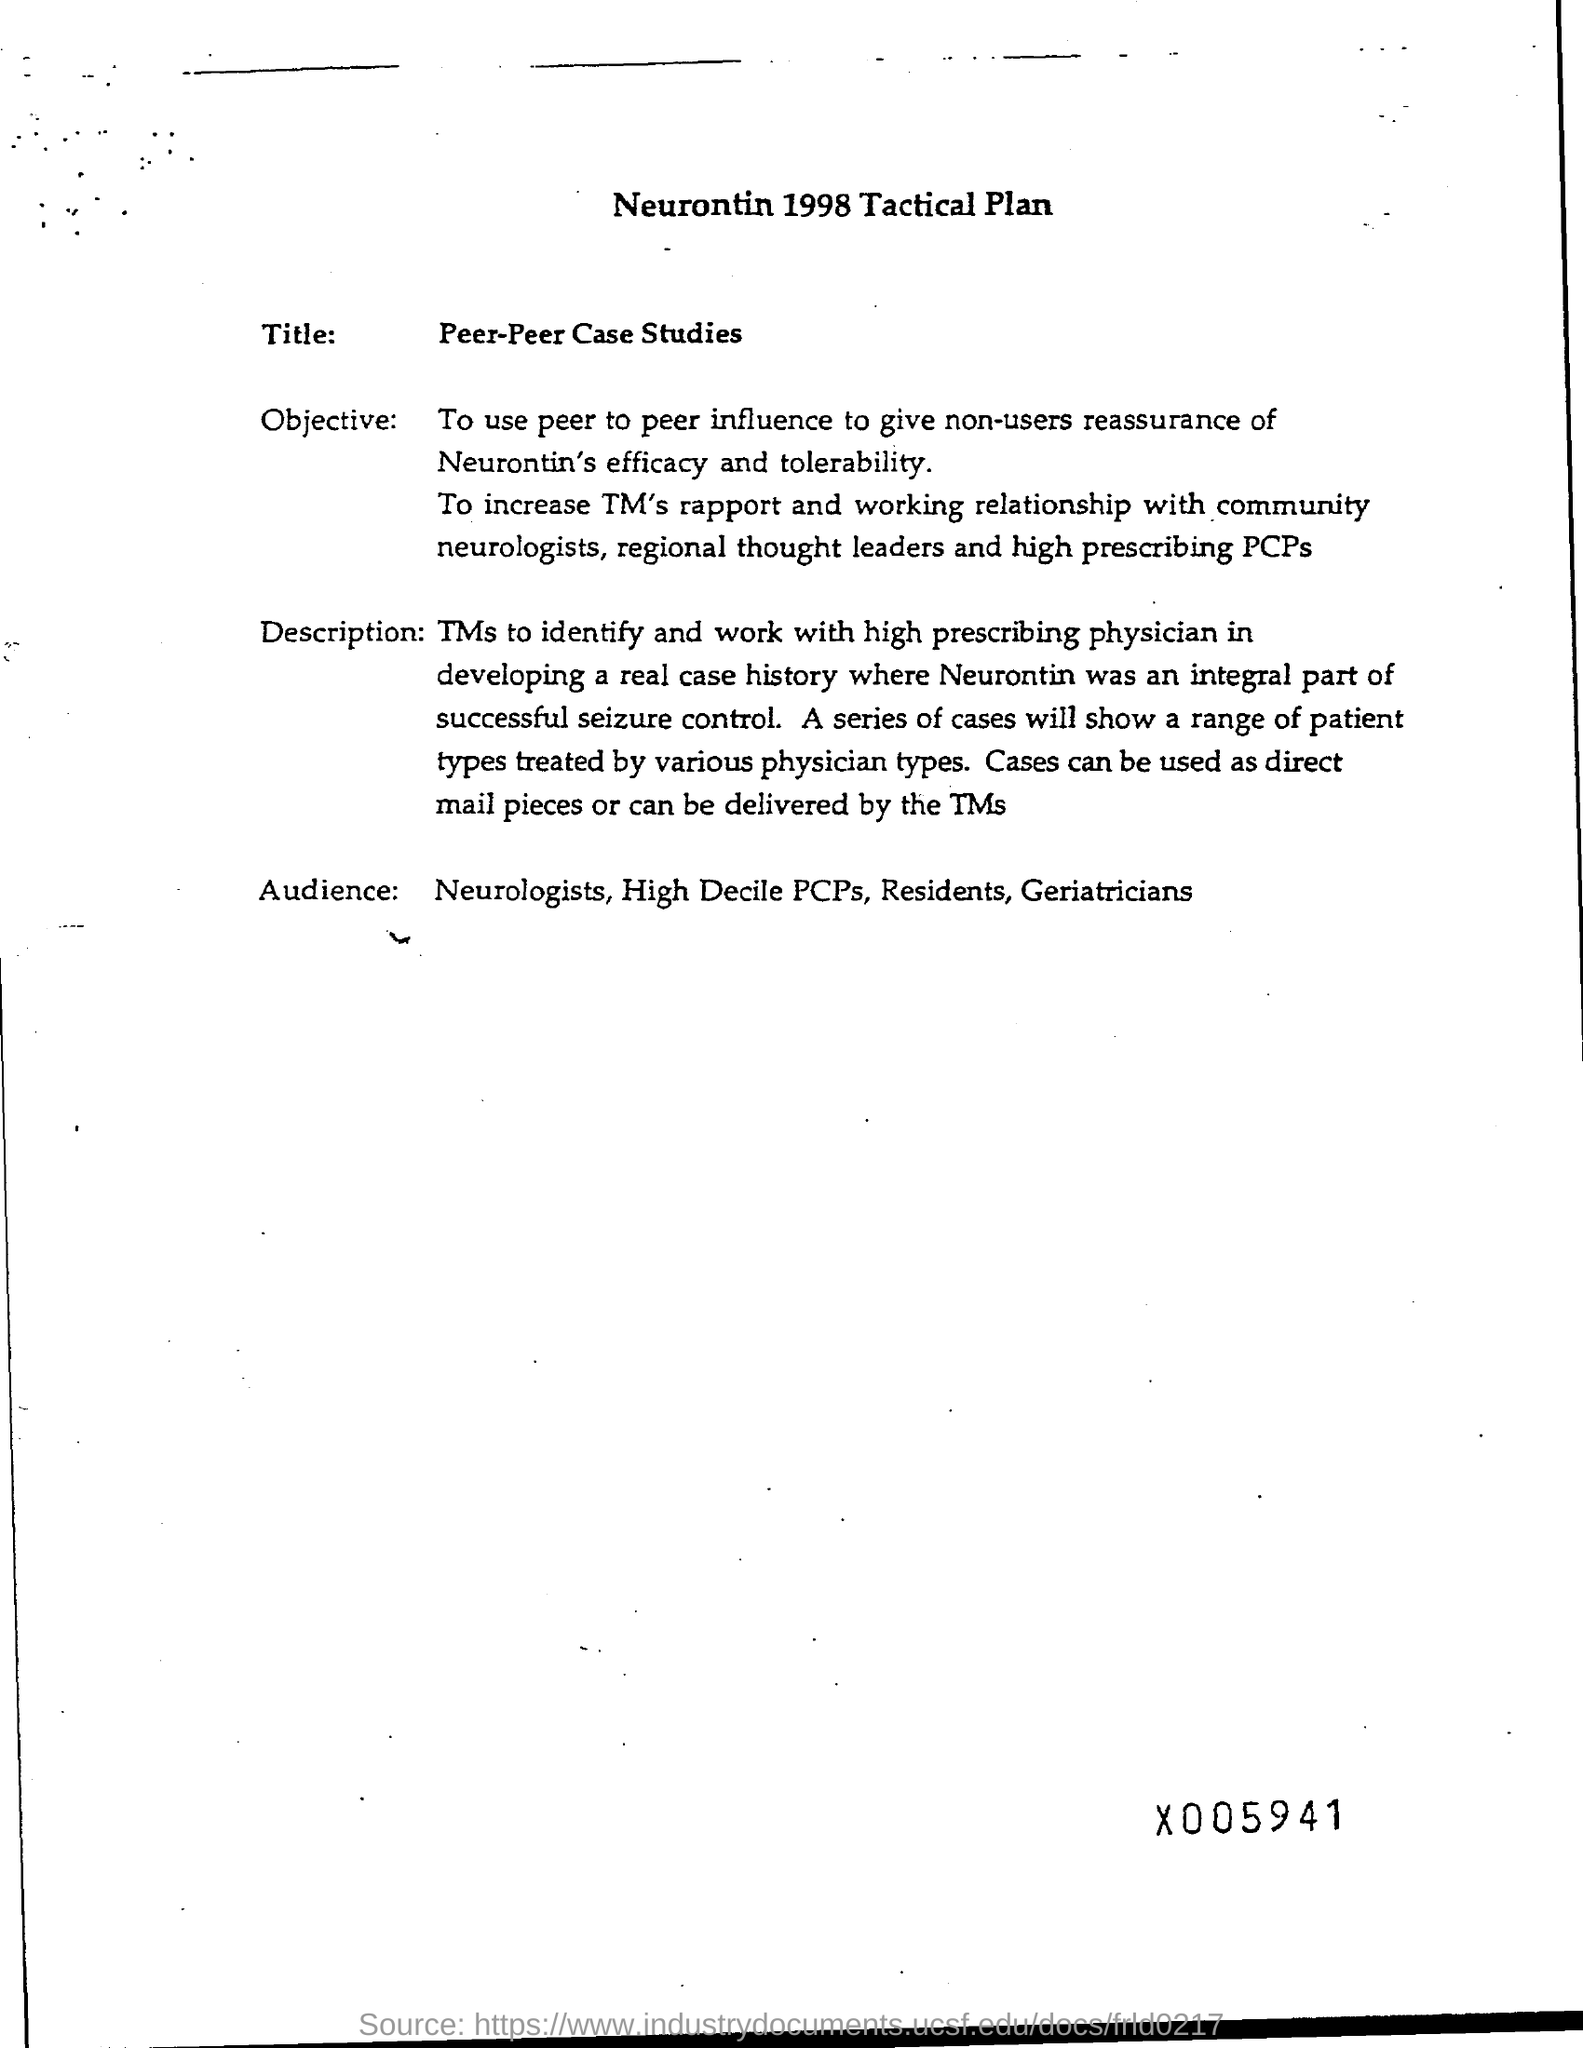List a handful of essential elements in this visual. The document is titled 'Neurontin 1998 Tactical Plan.' The title of this document is 'Peer-Peer Case Studies: What is it?' 